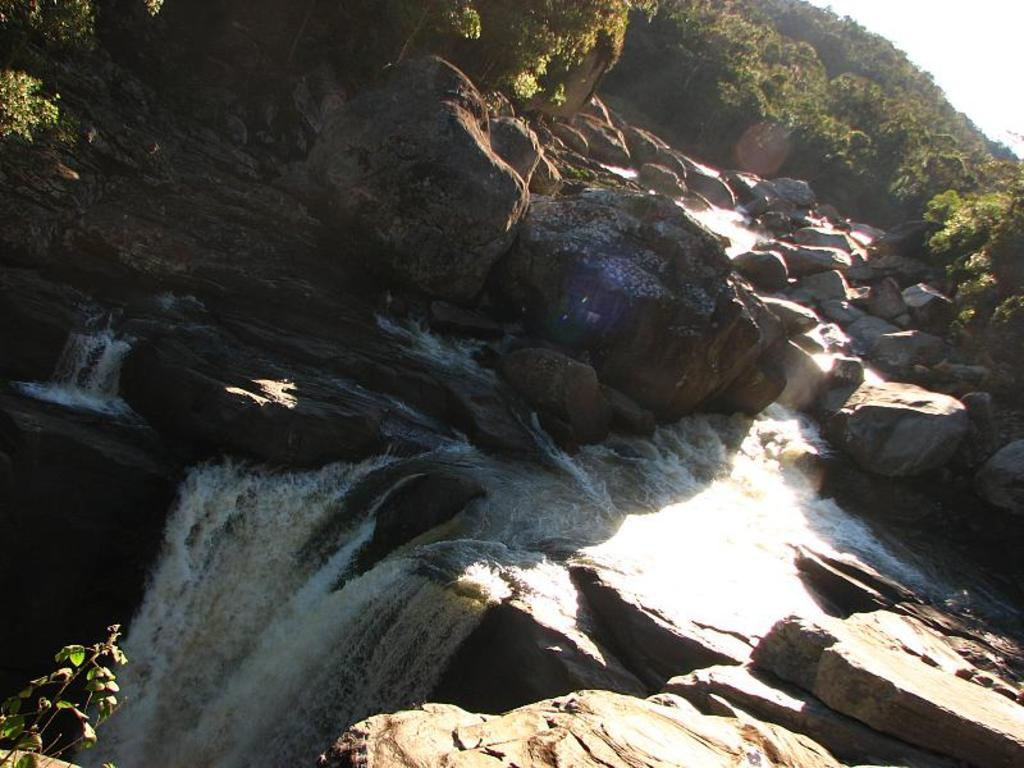What natural feature is the main subject of the image? There is a waterfall in the image. What type of geological formation can be seen in the image? There are rocks in the image. What type of vegetation is present in the image? There are trees in the image. What is visible in the background of the image? The sky is visible in the image. Can you see any clams or beans in the image? No, there are no clams or beans present in the image. What shape is the waterfall in the image? The shape of the waterfall cannot be determined from the image alone. 